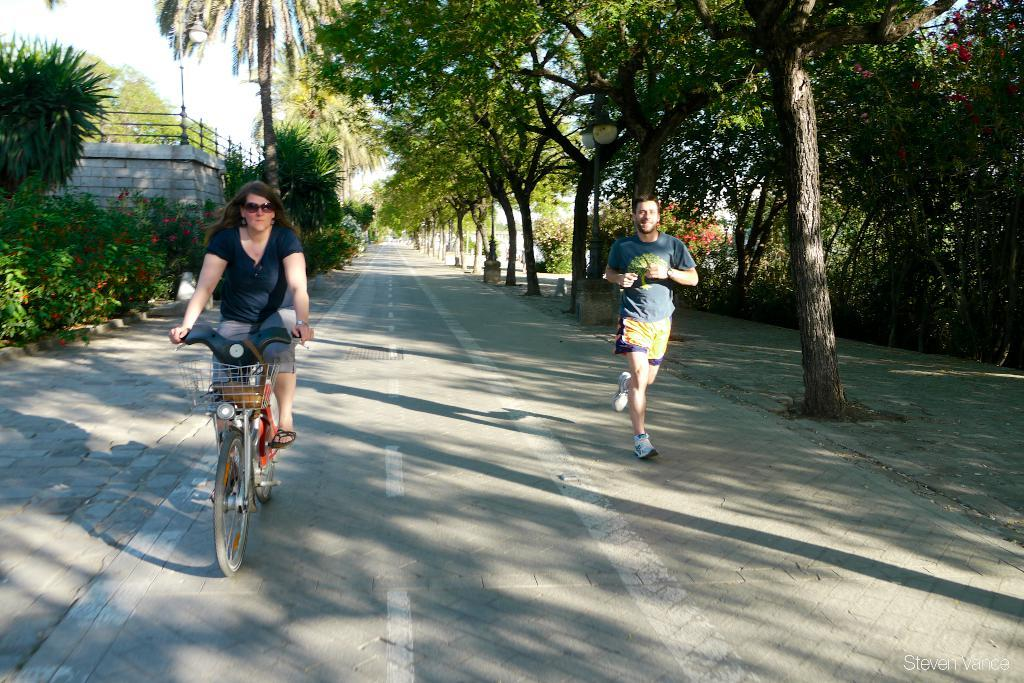What is the woman doing in the image? The woman is riding a bicycle on the road. What is the other person doing in the image? The other person is running on the road. What can be seen near the road in the image? Trees are visible near the road. What structure is present in the image? There is a wall in the image. What type of flag is being waved by the committee in the image? There is no flag or committee present in the image; it features a woman riding a bicycle and a person running on the road. What ornament is hanging from the wall in the image? There is no ornament hanging from the wall in the image; only a wall is present. 